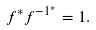<formula> <loc_0><loc_0><loc_500><loc_500>f ^ { * } f ^ { - 1 ^ { * } } = 1 .</formula> 